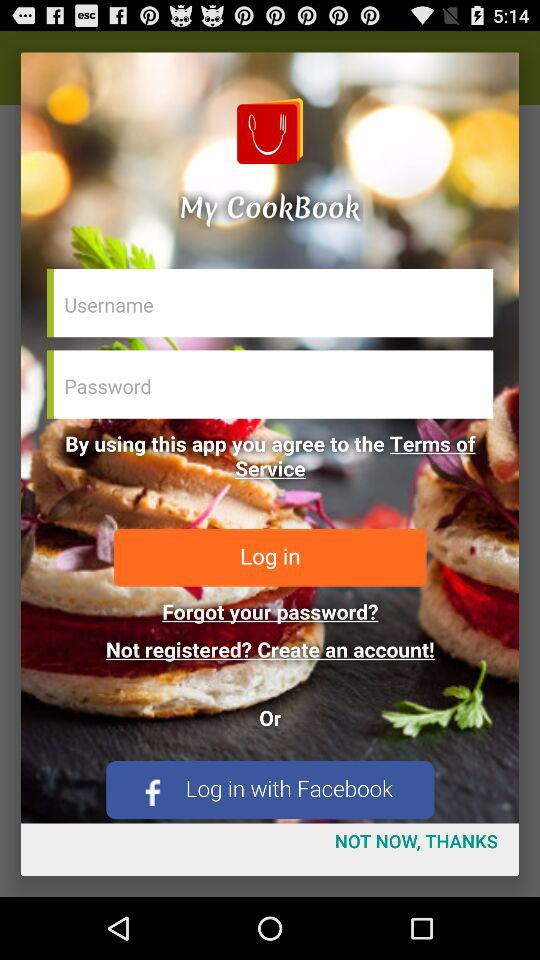When was the most recent recipe added to the application?
When the provided information is insufficient, respond with <no answer>. <no answer> 